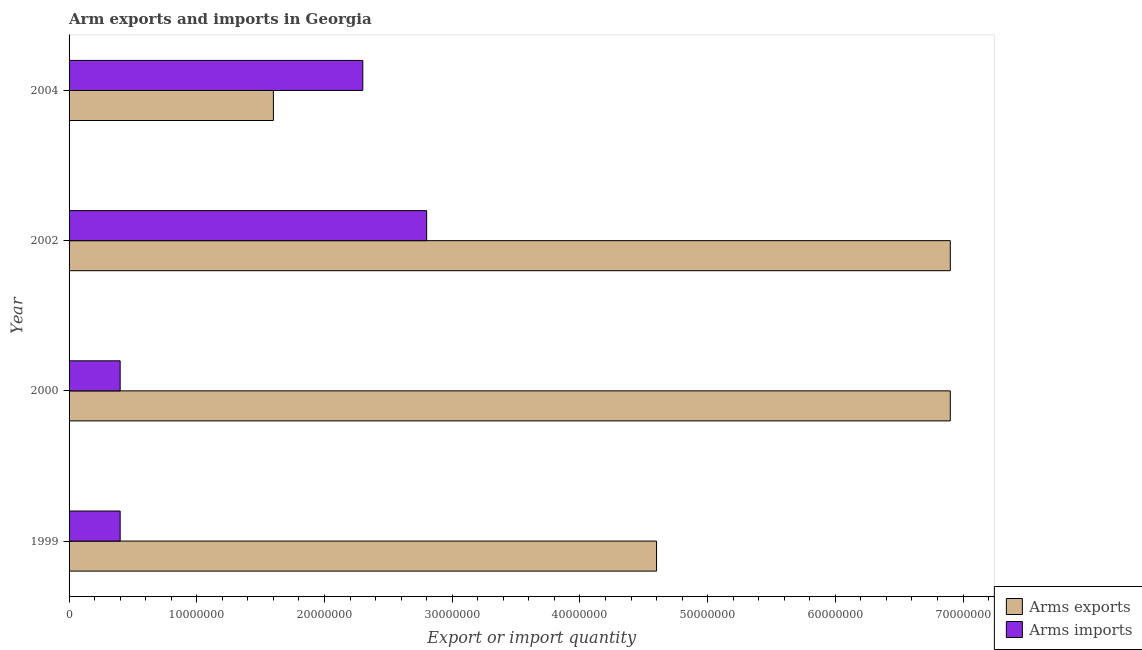Are the number of bars per tick equal to the number of legend labels?
Your answer should be compact. Yes. How many bars are there on the 2nd tick from the top?
Make the answer very short. 2. What is the label of the 1st group of bars from the top?
Make the answer very short. 2004. In how many cases, is the number of bars for a given year not equal to the number of legend labels?
Keep it short and to the point. 0. What is the arms imports in 1999?
Offer a terse response. 4.00e+06. Across all years, what is the maximum arms imports?
Your answer should be compact. 2.80e+07. Across all years, what is the minimum arms imports?
Give a very brief answer. 4.00e+06. In which year was the arms exports maximum?
Ensure brevity in your answer.  2000. In which year was the arms exports minimum?
Keep it short and to the point. 2004. What is the total arms imports in the graph?
Keep it short and to the point. 5.90e+07. What is the difference between the arms imports in 2000 and that in 2004?
Offer a terse response. -1.90e+07. What is the difference between the arms exports in 1999 and the arms imports in 2000?
Ensure brevity in your answer.  4.20e+07. In the year 2004, what is the difference between the arms imports and arms exports?
Offer a terse response. 7.00e+06. What is the ratio of the arms exports in 1999 to that in 2000?
Keep it short and to the point. 0.67. Is the difference between the arms imports in 2002 and 2004 greater than the difference between the arms exports in 2002 and 2004?
Your response must be concise. No. What is the difference between the highest and the lowest arms exports?
Make the answer very short. 5.30e+07. Is the sum of the arms imports in 1999 and 2002 greater than the maximum arms exports across all years?
Give a very brief answer. No. What does the 1st bar from the top in 2000 represents?
Your response must be concise. Arms imports. What does the 2nd bar from the bottom in 2004 represents?
Your answer should be compact. Arms imports. How many years are there in the graph?
Make the answer very short. 4. Does the graph contain any zero values?
Give a very brief answer. No. Does the graph contain grids?
Your response must be concise. No. What is the title of the graph?
Offer a very short reply. Arm exports and imports in Georgia. Does "Infant" appear as one of the legend labels in the graph?
Your answer should be very brief. No. What is the label or title of the X-axis?
Provide a short and direct response. Export or import quantity. What is the Export or import quantity of Arms exports in 1999?
Ensure brevity in your answer.  4.60e+07. What is the Export or import quantity of Arms imports in 1999?
Your answer should be very brief. 4.00e+06. What is the Export or import quantity in Arms exports in 2000?
Your answer should be compact. 6.90e+07. What is the Export or import quantity of Arms exports in 2002?
Offer a very short reply. 6.90e+07. What is the Export or import quantity in Arms imports in 2002?
Offer a terse response. 2.80e+07. What is the Export or import quantity in Arms exports in 2004?
Provide a short and direct response. 1.60e+07. What is the Export or import quantity of Arms imports in 2004?
Your response must be concise. 2.30e+07. Across all years, what is the maximum Export or import quantity in Arms exports?
Your response must be concise. 6.90e+07. Across all years, what is the maximum Export or import quantity in Arms imports?
Your answer should be very brief. 2.80e+07. Across all years, what is the minimum Export or import quantity in Arms exports?
Provide a succinct answer. 1.60e+07. Across all years, what is the minimum Export or import quantity in Arms imports?
Keep it short and to the point. 4.00e+06. What is the total Export or import quantity of Arms imports in the graph?
Provide a short and direct response. 5.90e+07. What is the difference between the Export or import quantity of Arms exports in 1999 and that in 2000?
Offer a very short reply. -2.30e+07. What is the difference between the Export or import quantity of Arms exports in 1999 and that in 2002?
Your answer should be compact. -2.30e+07. What is the difference between the Export or import quantity of Arms imports in 1999 and that in 2002?
Offer a very short reply. -2.40e+07. What is the difference between the Export or import quantity of Arms exports in 1999 and that in 2004?
Your answer should be very brief. 3.00e+07. What is the difference between the Export or import quantity of Arms imports in 1999 and that in 2004?
Keep it short and to the point. -1.90e+07. What is the difference between the Export or import quantity of Arms imports in 2000 and that in 2002?
Your answer should be very brief. -2.40e+07. What is the difference between the Export or import quantity of Arms exports in 2000 and that in 2004?
Offer a very short reply. 5.30e+07. What is the difference between the Export or import quantity in Arms imports in 2000 and that in 2004?
Offer a very short reply. -1.90e+07. What is the difference between the Export or import quantity in Arms exports in 2002 and that in 2004?
Give a very brief answer. 5.30e+07. What is the difference between the Export or import quantity in Arms imports in 2002 and that in 2004?
Your answer should be very brief. 5.00e+06. What is the difference between the Export or import quantity in Arms exports in 1999 and the Export or import quantity in Arms imports in 2000?
Offer a terse response. 4.20e+07. What is the difference between the Export or import quantity in Arms exports in 1999 and the Export or import quantity in Arms imports in 2002?
Keep it short and to the point. 1.80e+07. What is the difference between the Export or import quantity in Arms exports in 1999 and the Export or import quantity in Arms imports in 2004?
Offer a terse response. 2.30e+07. What is the difference between the Export or import quantity of Arms exports in 2000 and the Export or import quantity of Arms imports in 2002?
Your answer should be very brief. 4.10e+07. What is the difference between the Export or import quantity in Arms exports in 2000 and the Export or import quantity in Arms imports in 2004?
Your response must be concise. 4.60e+07. What is the difference between the Export or import quantity of Arms exports in 2002 and the Export or import quantity of Arms imports in 2004?
Provide a short and direct response. 4.60e+07. What is the average Export or import quantity in Arms exports per year?
Keep it short and to the point. 5.00e+07. What is the average Export or import quantity in Arms imports per year?
Provide a succinct answer. 1.48e+07. In the year 1999, what is the difference between the Export or import quantity of Arms exports and Export or import quantity of Arms imports?
Your answer should be very brief. 4.20e+07. In the year 2000, what is the difference between the Export or import quantity in Arms exports and Export or import quantity in Arms imports?
Ensure brevity in your answer.  6.50e+07. In the year 2002, what is the difference between the Export or import quantity of Arms exports and Export or import quantity of Arms imports?
Give a very brief answer. 4.10e+07. In the year 2004, what is the difference between the Export or import quantity of Arms exports and Export or import quantity of Arms imports?
Your response must be concise. -7.00e+06. What is the ratio of the Export or import quantity in Arms imports in 1999 to that in 2000?
Provide a short and direct response. 1. What is the ratio of the Export or import quantity of Arms imports in 1999 to that in 2002?
Ensure brevity in your answer.  0.14. What is the ratio of the Export or import quantity of Arms exports in 1999 to that in 2004?
Offer a terse response. 2.88. What is the ratio of the Export or import quantity of Arms imports in 1999 to that in 2004?
Offer a very short reply. 0.17. What is the ratio of the Export or import quantity in Arms imports in 2000 to that in 2002?
Provide a short and direct response. 0.14. What is the ratio of the Export or import quantity in Arms exports in 2000 to that in 2004?
Give a very brief answer. 4.31. What is the ratio of the Export or import quantity in Arms imports in 2000 to that in 2004?
Provide a succinct answer. 0.17. What is the ratio of the Export or import quantity of Arms exports in 2002 to that in 2004?
Your answer should be compact. 4.31. What is the ratio of the Export or import quantity of Arms imports in 2002 to that in 2004?
Offer a very short reply. 1.22. What is the difference between the highest and the second highest Export or import quantity in Arms imports?
Offer a terse response. 5.00e+06. What is the difference between the highest and the lowest Export or import quantity in Arms exports?
Give a very brief answer. 5.30e+07. What is the difference between the highest and the lowest Export or import quantity in Arms imports?
Give a very brief answer. 2.40e+07. 